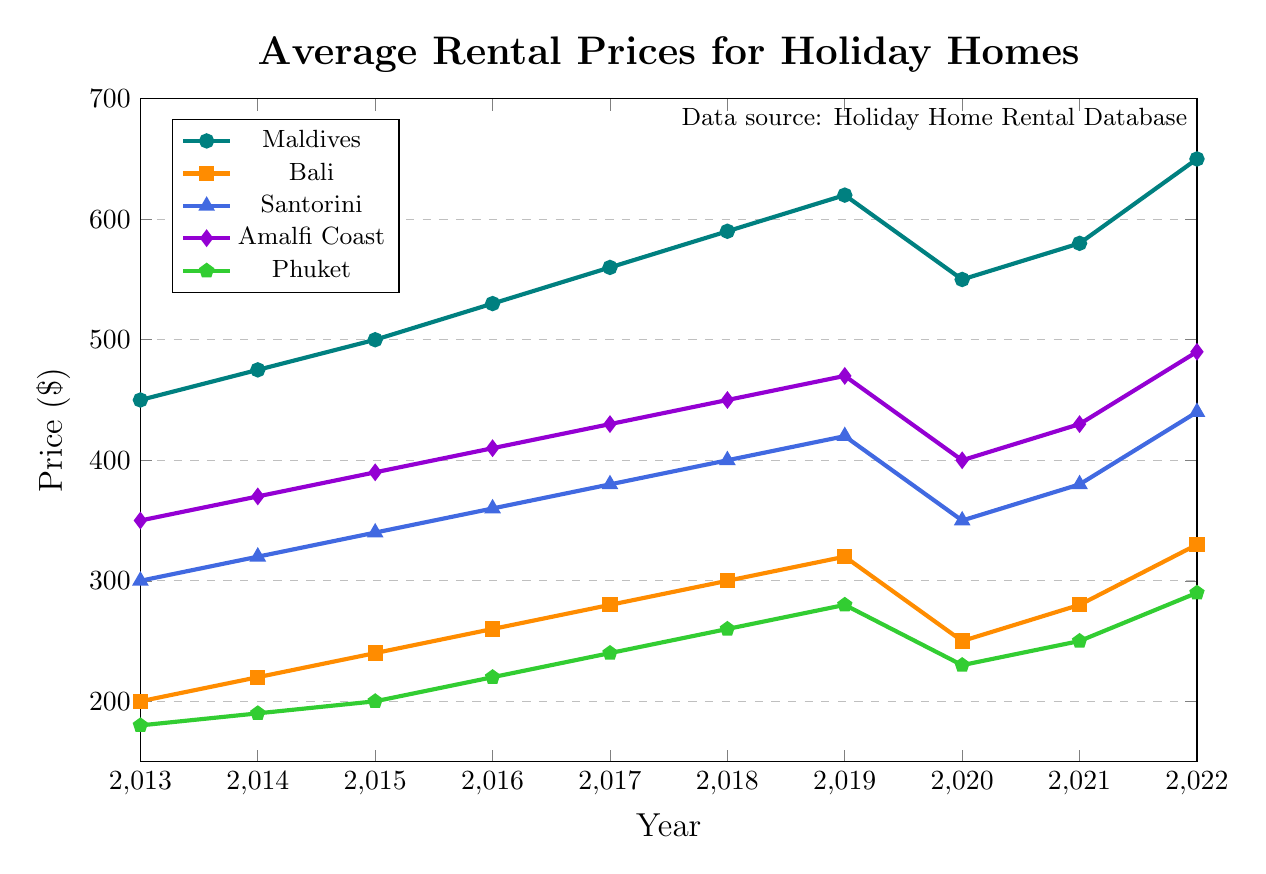What was the average rental price in the Maldives over the decade? To find the average rental price, sum all the prices for the Maldives from 2013 to 2022 and then divide by the number of years. The total sum is 450 + 475 + 500 + 530 + 560 + 590 + 620 + 550 + 580 + 650 = 5505. There are 10 years, so the average is 5505 / 10 = 550.5
Answer: 550.5 Which destination had the highest rental price in 2022? From the data, we observe the prices in 2022: Maldives (650), Bali (330), Santorini (440), Amalfi Coast (490), Phuket (290). The highest price is for the Maldives at 650.
Answer: Maldives How did the rental prices in Phuket change between 2019 and 2020? The rental price in Phuket was 280 in 2019 and 230 in 2020. The change is calculated by 230 - 280, resulting in a decrease of 50.
Answer: Decreased by 50 Which year did Santorini experience the greatest decrease in rental prices? To find the greatest decrease, compare the prices year-over-year for Santorini: 2019 to 2020 (420 - 350 = 70) shows the largest drop at 70 units.
Answer: 2020 What was the combined rental price of Santorini and Amalfi Coast in 2016? The prices in 2016 are Santorini (360) and Amalfi Coast (410). Summing them gives 360 + 410 = 770.
Answer: 770 In which year did Bali have the lowest rental price? The lowest rental price for Bali is 200 in the year 2013.
Answer: 2013 Which destination had the steadiest increase in rental prices without any decrease? Observing the trends: Maldives, Santorini, and Amalfi Coast each had periods of increase and decrease. Bali and Phuket remained either steady or increasing except for small fluctuations. Bali maintained steady increases without any notable decreases between years.
Answer: Bali By how much did the rental prices in the Maldives increase from 2013 to 2022? The price in 2013 was 450, and in 2022 it was 650. The increase is calculated as 650 - 450 = 200.
Answer: 200 Compare the rental price trends between the Maldives and Phuket in 2020. What can you infer? In 2020, Maldives had 550, Phuket had 230—a significant drop in both cases compared to the previous year, where Maldives was 620, and Phuket was 280. Both destinations experienced a decrease in rental prices in 2020 after a previous increase in the preceding years.
Answer: Both saw a decrease Which destination saw the largest increase in rental prices from 2021 to 2022? Comparing the prices in 2021 and 2022: 
    - Maldives: 580 to 650 (increase of 70)
    - Bali: 280 to 330 (increase of 50)
    - Santorini: 380 to 440 (increase of 60)
    - Amalfi Coast: 430 to 490 (increase of 60)
    - Phuket: 250 to 290 (increase of 40)
The Maldives saw the largest increase of 70.
Answer: Maldives 